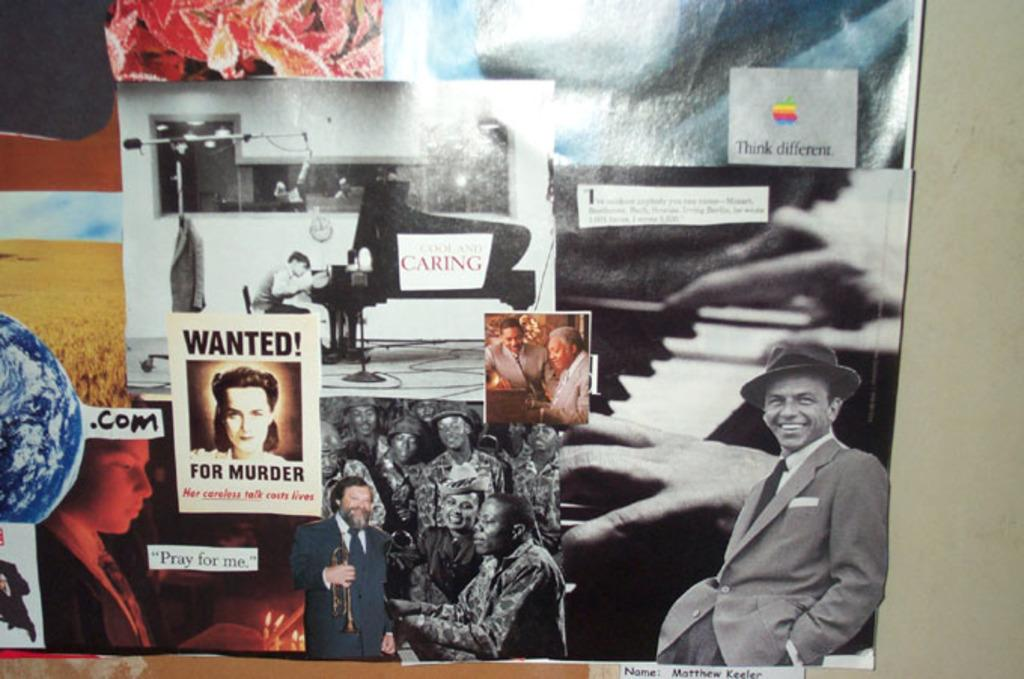What can be seen on the wall in the image? There are different posters on the wall. Can you describe the images on the posters? Each poster has a different image. What color is the background of the image? The background color is gray. What is the distribution of disgust in the image? There is no mention of disgust or any emotion in the image; it only features posters with different images and a gray background. 